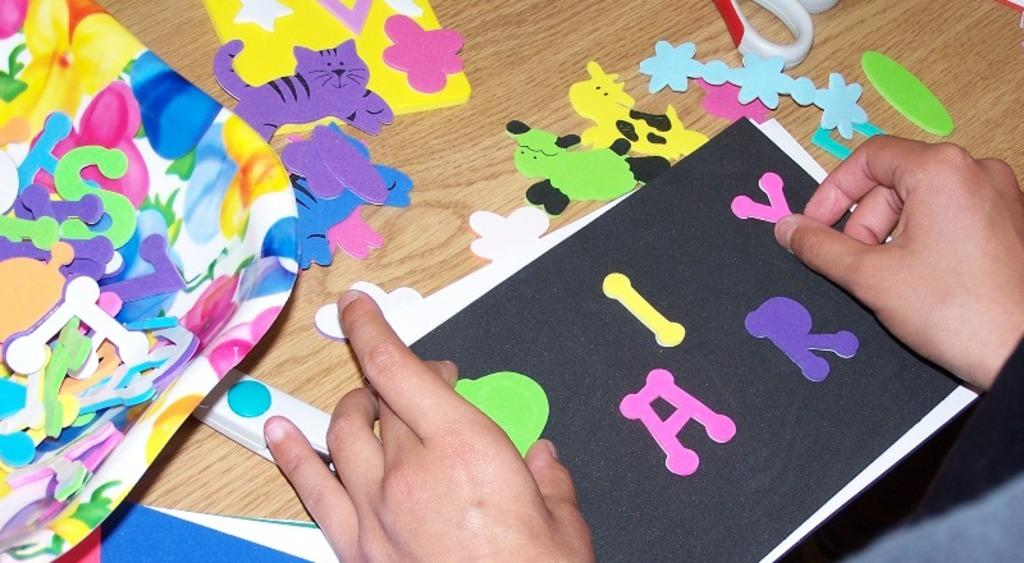What type of toys are in the image? There are paper toys in the image. What surface are the paper toys placed on? The paper toys are on a wooden surface. Can you describe any other elements in the image? A person's hand is visible in the image. What type of education can be seen in the image? There is no reference to education in the image; it features paper toys on a wooden surface and a person's hand. How many dogs are present in the image? There are no dogs present in the image. 